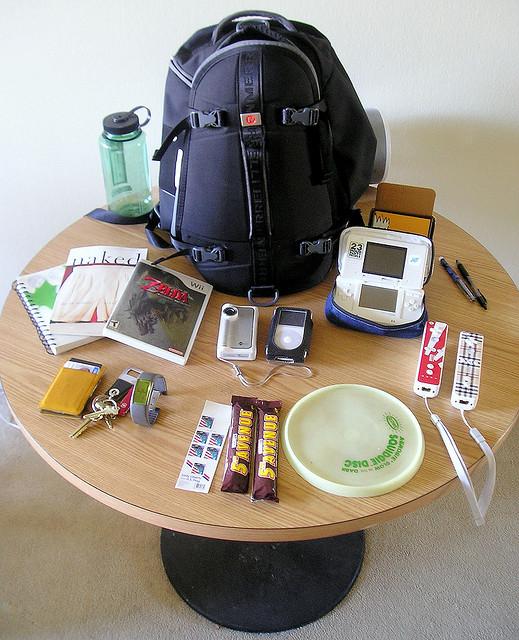Where is the water bottle?
Be succinct. On table. Is there any food on the table?
Give a very brief answer. Yes. Why is this stuff on the table?
Keep it brief. Packing. 